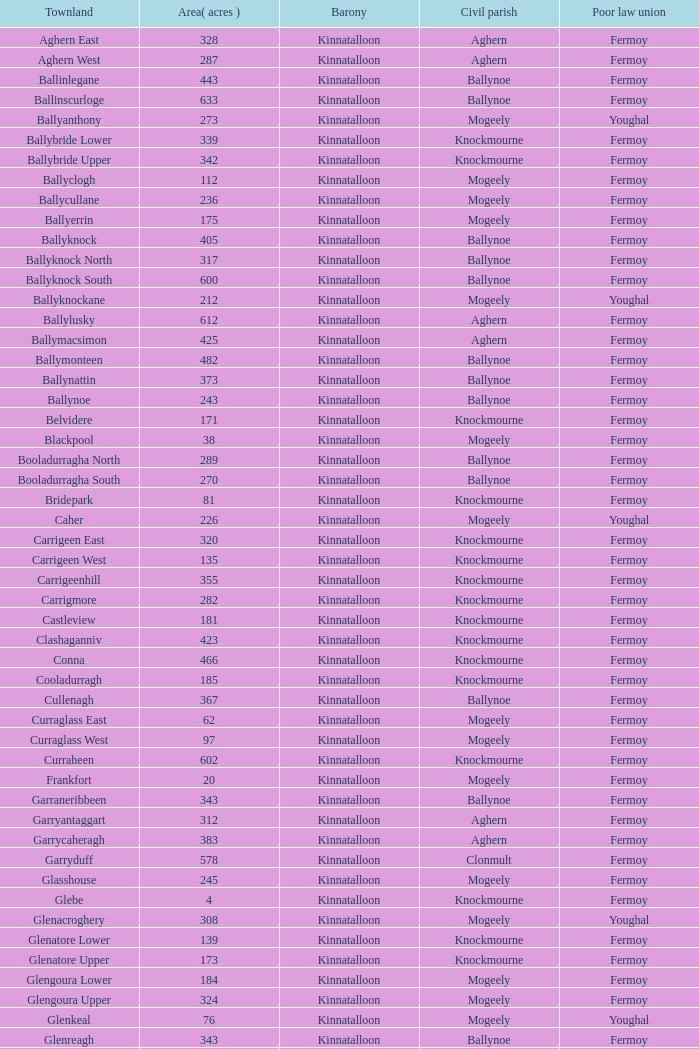Can you identify the townland that includes fermoy and ballynoe? Ballinlegane, Ballinscurloge, Ballyknock, Ballyknock North, Ballyknock South, Ballymonteen, Ballynattin, Ballynoe, Booladurragha North, Booladurragha South, Cullenagh, Garraneribbeen, Glenreagh, Glentane, Killasseragh, Kilphillibeen, Knockakeo, Longueville North, Longueville South, Rathdrum, Shanaboola. 